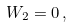<formula> <loc_0><loc_0><loc_500><loc_500>W _ { 2 } = 0 \, ,</formula> 